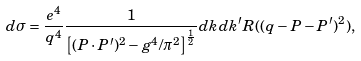<formula> <loc_0><loc_0><loc_500><loc_500>d \sigma = \frac { e ^ { 4 } } { q ^ { 4 } } \frac { 1 } { \left [ ( P \cdot P ^ { \prime } ) ^ { 2 } - g ^ { 4 } / { \pi ^ { 2 } } \right ] ^ { \frac { 1 } { 2 } } } d k d k ^ { \prime } R ( ( q - P - P ^ { \prime } ) ^ { 2 } ) ,</formula> 